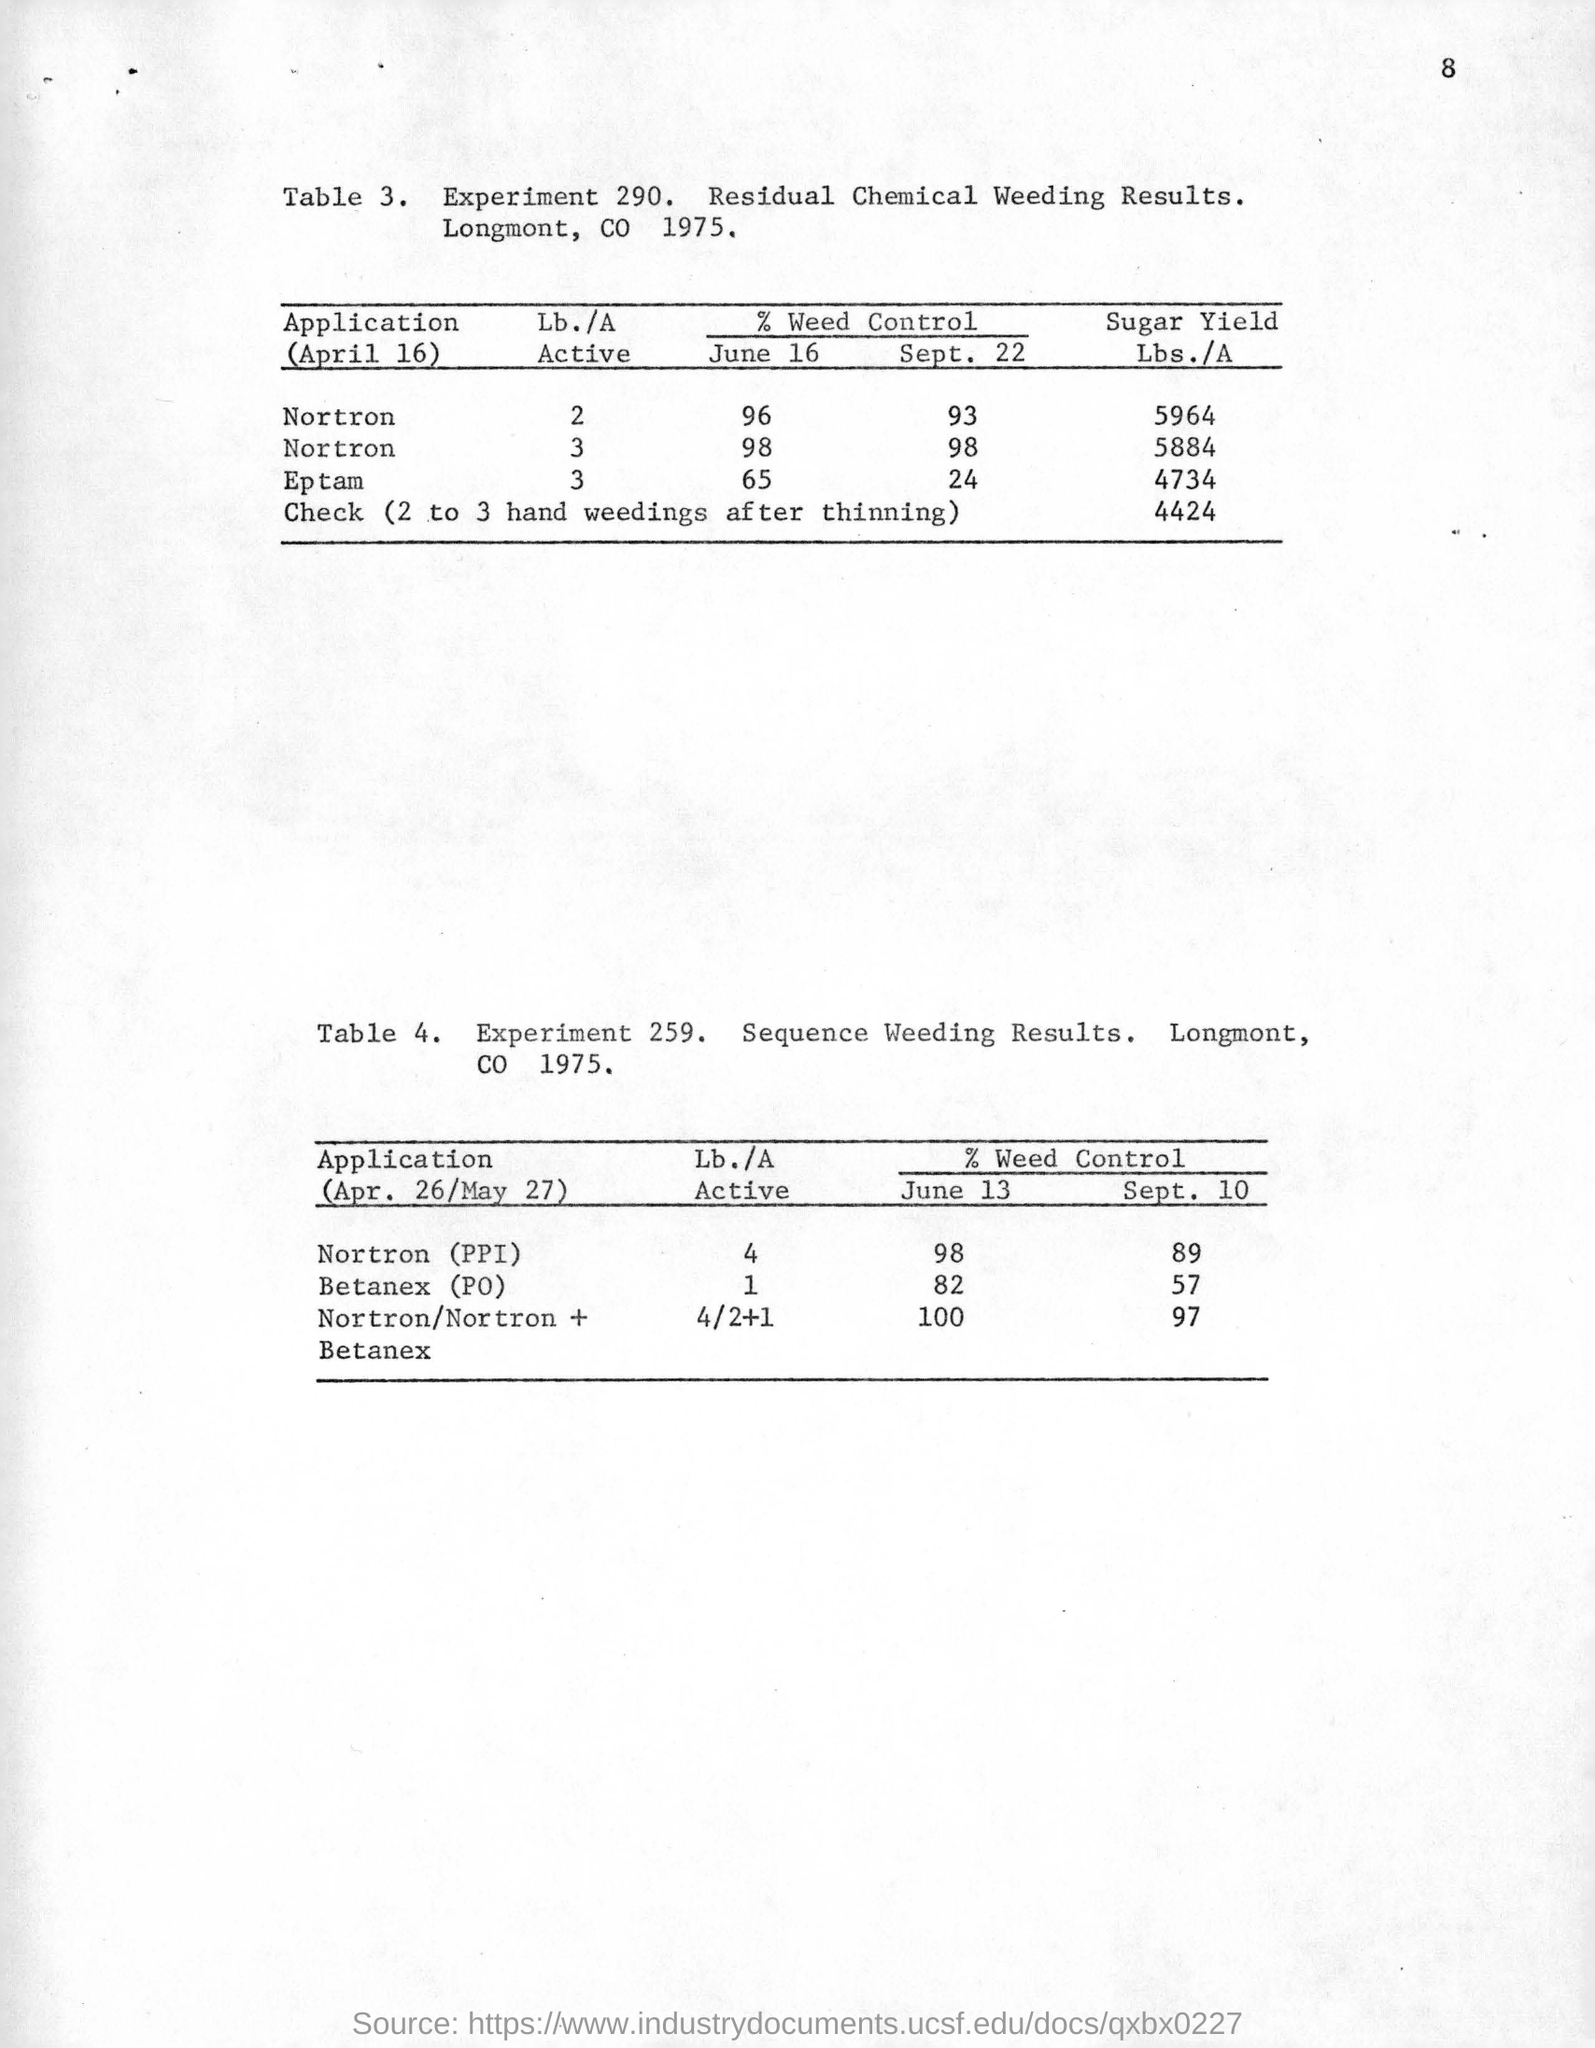Identify some key points in this picture. The experiment number for residual chemical weeding is 290, as denoted in Experiment 290... The Sequence Weeding Results experiment is mentioned in Table 4 of the given text. 